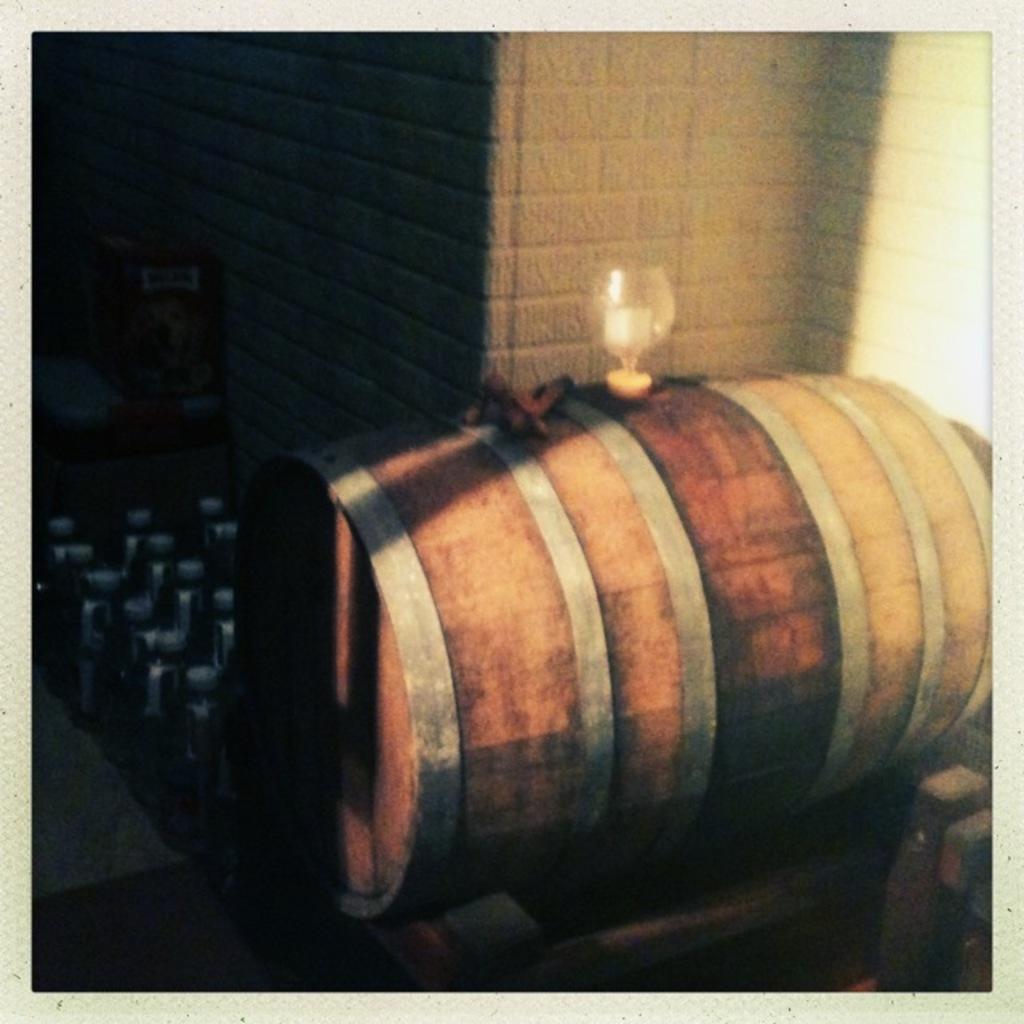Can you describe this image briefly? In the picture I can see a wooden object which has a glass placed on it and there are few objects and a wall in the background. 